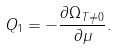Convert formula to latex. <formula><loc_0><loc_0><loc_500><loc_500>Q _ { 1 } = - \frac { \partial \Omega _ { T \neq 0 } } { \partial \mu } .</formula> 